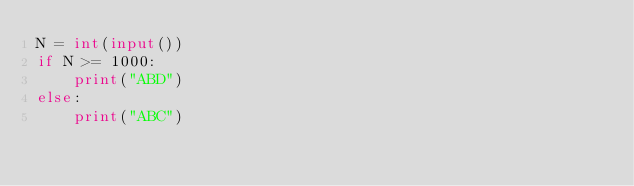Convert code to text. <code><loc_0><loc_0><loc_500><loc_500><_Python_>N = int(input())
if N >= 1000:
    print("ABD")
else:
    print("ABC")</code> 